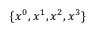Convert formula to latex. <formula><loc_0><loc_0><loc_500><loc_500>\{ x ^ { 0 } , x ^ { 1 } , x ^ { 2 } , x ^ { 3 } \}</formula> 